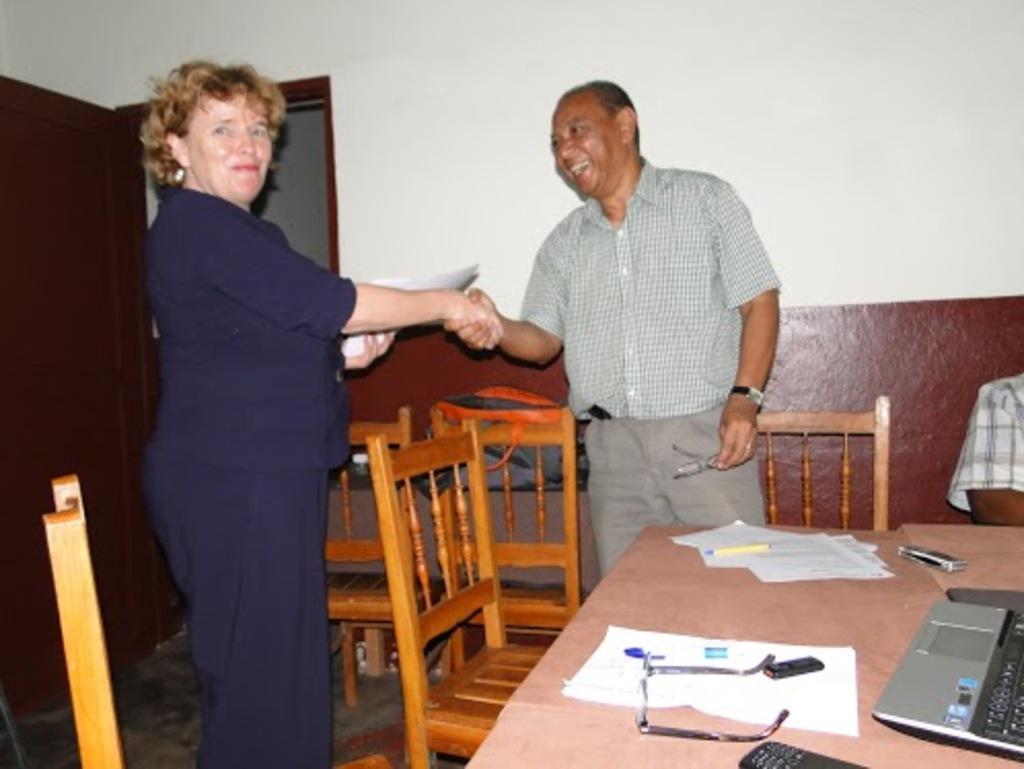Please provide a concise description of this image. In this picture there are two members standing, shaking their hands. One is woman and the other is a man. Both of them were smiling. There are some chairs ad a table on which a laptop, papers, spectacles were placed. 